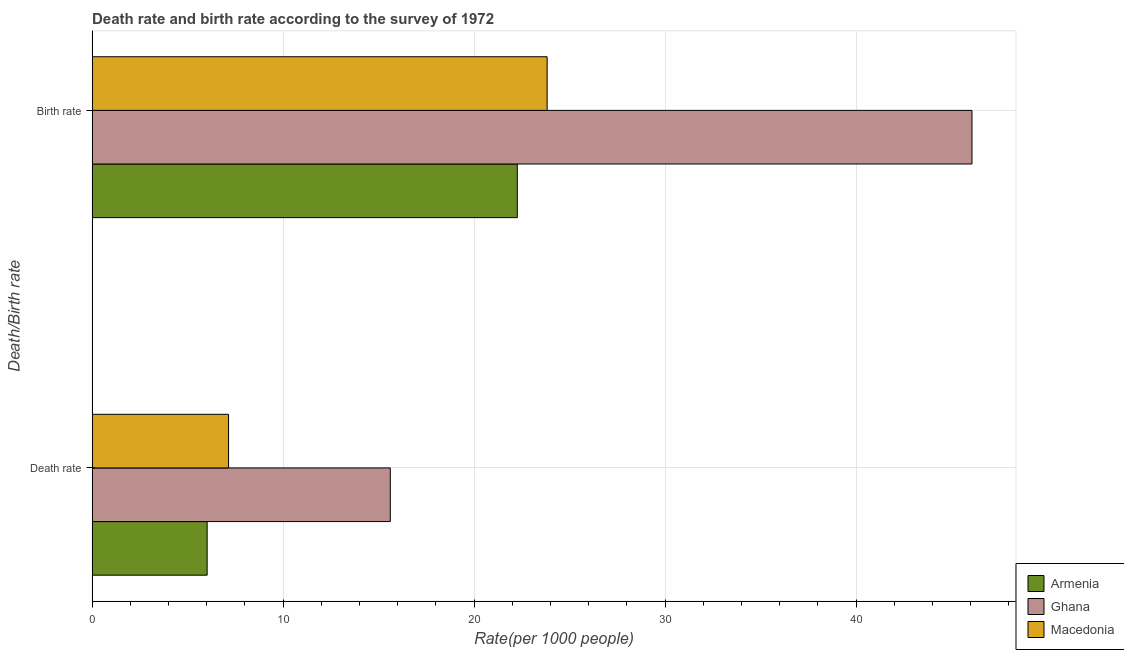How many groups of bars are there?
Your answer should be very brief. 2. Are the number of bars on each tick of the Y-axis equal?
Keep it short and to the point. Yes. How many bars are there on the 2nd tick from the bottom?
Offer a very short reply. 3. What is the label of the 1st group of bars from the top?
Give a very brief answer. Birth rate. What is the death rate in Ghana?
Your answer should be compact. 15.61. Across all countries, what is the maximum death rate?
Give a very brief answer. 15.61. Across all countries, what is the minimum birth rate?
Provide a short and direct response. 22.26. In which country was the death rate maximum?
Your answer should be very brief. Ghana. In which country was the death rate minimum?
Offer a very short reply. Armenia. What is the total death rate in the graph?
Give a very brief answer. 28.78. What is the difference between the birth rate in Macedonia and that in Armenia?
Offer a terse response. 1.56. What is the difference between the death rate in Ghana and the birth rate in Armenia?
Offer a very short reply. -6.65. What is the average birth rate per country?
Ensure brevity in your answer.  30.72. What is the difference between the death rate and birth rate in Ghana?
Your answer should be very brief. -30.46. What is the ratio of the birth rate in Macedonia to that in Armenia?
Make the answer very short. 1.07. Is the birth rate in Armenia less than that in Macedonia?
Provide a short and direct response. Yes. In how many countries, is the birth rate greater than the average birth rate taken over all countries?
Your response must be concise. 1. What does the 1st bar from the top in Death rate represents?
Keep it short and to the point. Macedonia. What does the 2nd bar from the bottom in Birth rate represents?
Your response must be concise. Ghana. How many bars are there?
Your answer should be compact. 6. Are all the bars in the graph horizontal?
Your response must be concise. Yes. How many countries are there in the graph?
Your response must be concise. 3. Does the graph contain grids?
Provide a short and direct response. Yes. How are the legend labels stacked?
Make the answer very short. Vertical. What is the title of the graph?
Keep it short and to the point. Death rate and birth rate according to the survey of 1972. Does "Sudan" appear as one of the legend labels in the graph?
Give a very brief answer. No. What is the label or title of the X-axis?
Provide a succinct answer. Rate(per 1000 people). What is the label or title of the Y-axis?
Provide a succinct answer. Death/Birth rate. What is the Rate(per 1000 people) in Armenia in Death rate?
Provide a succinct answer. 6.02. What is the Rate(per 1000 people) of Ghana in Death rate?
Provide a succinct answer. 15.61. What is the Rate(per 1000 people) in Macedonia in Death rate?
Offer a very short reply. 7.15. What is the Rate(per 1000 people) of Armenia in Birth rate?
Your answer should be very brief. 22.26. What is the Rate(per 1000 people) of Ghana in Birth rate?
Provide a succinct answer. 46.07. What is the Rate(per 1000 people) in Macedonia in Birth rate?
Make the answer very short. 23.83. Across all Death/Birth rate, what is the maximum Rate(per 1000 people) of Armenia?
Your answer should be compact. 22.26. Across all Death/Birth rate, what is the maximum Rate(per 1000 people) in Ghana?
Make the answer very short. 46.07. Across all Death/Birth rate, what is the maximum Rate(per 1000 people) in Macedonia?
Give a very brief answer. 23.83. Across all Death/Birth rate, what is the minimum Rate(per 1000 people) of Armenia?
Your answer should be compact. 6.02. Across all Death/Birth rate, what is the minimum Rate(per 1000 people) in Ghana?
Make the answer very short. 15.61. Across all Death/Birth rate, what is the minimum Rate(per 1000 people) of Macedonia?
Your answer should be compact. 7.15. What is the total Rate(per 1000 people) in Armenia in the graph?
Your response must be concise. 28.29. What is the total Rate(per 1000 people) of Ghana in the graph?
Provide a succinct answer. 61.69. What is the total Rate(per 1000 people) of Macedonia in the graph?
Ensure brevity in your answer.  30.97. What is the difference between the Rate(per 1000 people) in Armenia in Death rate and that in Birth rate?
Keep it short and to the point. -16.24. What is the difference between the Rate(per 1000 people) of Ghana in Death rate and that in Birth rate?
Give a very brief answer. -30.46. What is the difference between the Rate(per 1000 people) of Macedonia in Death rate and that in Birth rate?
Keep it short and to the point. -16.68. What is the difference between the Rate(per 1000 people) in Armenia in Death rate and the Rate(per 1000 people) in Ghana in Birth rate?
Keep it short and to the point. -40.05. What is the difference between the Rate(per 1000 people) in Armenia in Death rate and the Rate(per 1000 people) in Macedonia in Birth rate?
Offer a terse response. -17.8. What is the difference between the Rate(per 1000 people) in Ghana in Death rate and the Rate(per 1000 people) in Macedonia in Birth rate?
Make the answer very short. -8.21. What is the average Rate(per 1000 people) of Armenia per Death/Birth rate?
Your response must be concise. 14.14. What is the average Rate(per 1000 people) of Ghana per Death/Birth rate?
Offer a terse response. 30.84. What is the average Rate(per 1000 people) in Macedonia per Death/Birth rate?
Your response must be concise. 15.49. What is the difference between the Rate(per 1000 people) in Armenia and Rate(per 1000 people) in Ghana in Death rate?
Provide a short and direct response. -9.59. What is the difference between the Rate(per 1000 people) of Armenia and Rate(per 1000 people) of Macedonia in Death rate?
Your answer should be compact. -1.12. What is the difference between the Rate(per 1000 people) in Ghana and Rate(per 1000 people) in Macedonia in Death rate?
Your answer should be very brief. 8.47. What is the difference between the Rate(per 1000 people) of Armenia and Rate(per 1000 people) of Ghana in Birth rate?
Offer a terse response. -23.81. What is the difference between the Rate(per 1000 people) of Armenia and Rate(per 1000 people) of Macedonia in Birth rate?
Your response must be concise. -1.56. What is the difference between the Rate(per 1000 people) in Ghana and Rate(per 1000 people) in Macedonia in Birth rate?
Provide a short and direct response. 22.25. What is the ratio of the Rate(per 1000 people) of Armenia in Death rate to that in Birth rate?
Offer a very short reply. 0.27. What is the ratio of the Rate(per 1000 people) in Ghana in Death rate to that in Birth rate?
Offer a very short reply. 0.34. What is the ratio of the Rate(per 1000 people) of Macedonia in Death rate to that in Birth rate?
Ensure brevity in your answer.  0.3. What is the difference between the highest and the second highest Rate(per 1000 people) of Armenia?
Your answer should be compact. 16.24. What is the difference between the highest and the second highest Rate(per 1000 people) of Ghana?
Offer a terse response. 30.46. What is the difference between the highest and the second highest Rate(per 1000 people) of Macedonia?
Provide a succinct answer. 16.68. What is the difference between the highest and the lowest Rate(per 1000 people) in Armenia?
Make the answer very short. 16.24. What is the difference between the highest and the lowest Rate(per 1000 people) in Ghana?
Your answer should be compact. 30.46. What is the difference between the highest and the lowest Rate(per 1000 people) in Macedonia?
Provide a succinct answer. 16.68. 